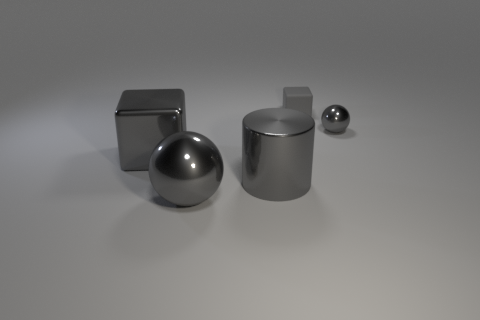What number of other objects are there of the same color as the big block?
Offer a very short reply. 4. What material is the cylinder that is the same color as the tiny rubber block?
Keep it short and to the point. Metal. There is a small thing that is behind the metal sphere that is behind the large metallic block; how many rubber objects are in front of it?
Provide a succinct answer. 0. There is a tiny gray matte object; does it have the same shape as the thing on the right side of the small matte block?
Keep it short and to the point. No. Are there more metallic cylinders than large brown metal objects?
Your response must be concise. Yes. Are there any other things that have the same size as the gray matte block?
Give a very brief answer. Yes. Is the shape of the big shiny object that is behind the big gray cylinder the same as  the gray rubber object?
Your answer should be very brief. Yes. Are there more gray cylinders in front of the large gray metallic cylinder than large gray shiny blocks?
Give a very brief answer. No. The object behind the shiny ball behind the big sphere is what color?
Ensure brevity in your answer.  Gray. How many large gray metallic objects are there?
Your answer should be compact. 3. 